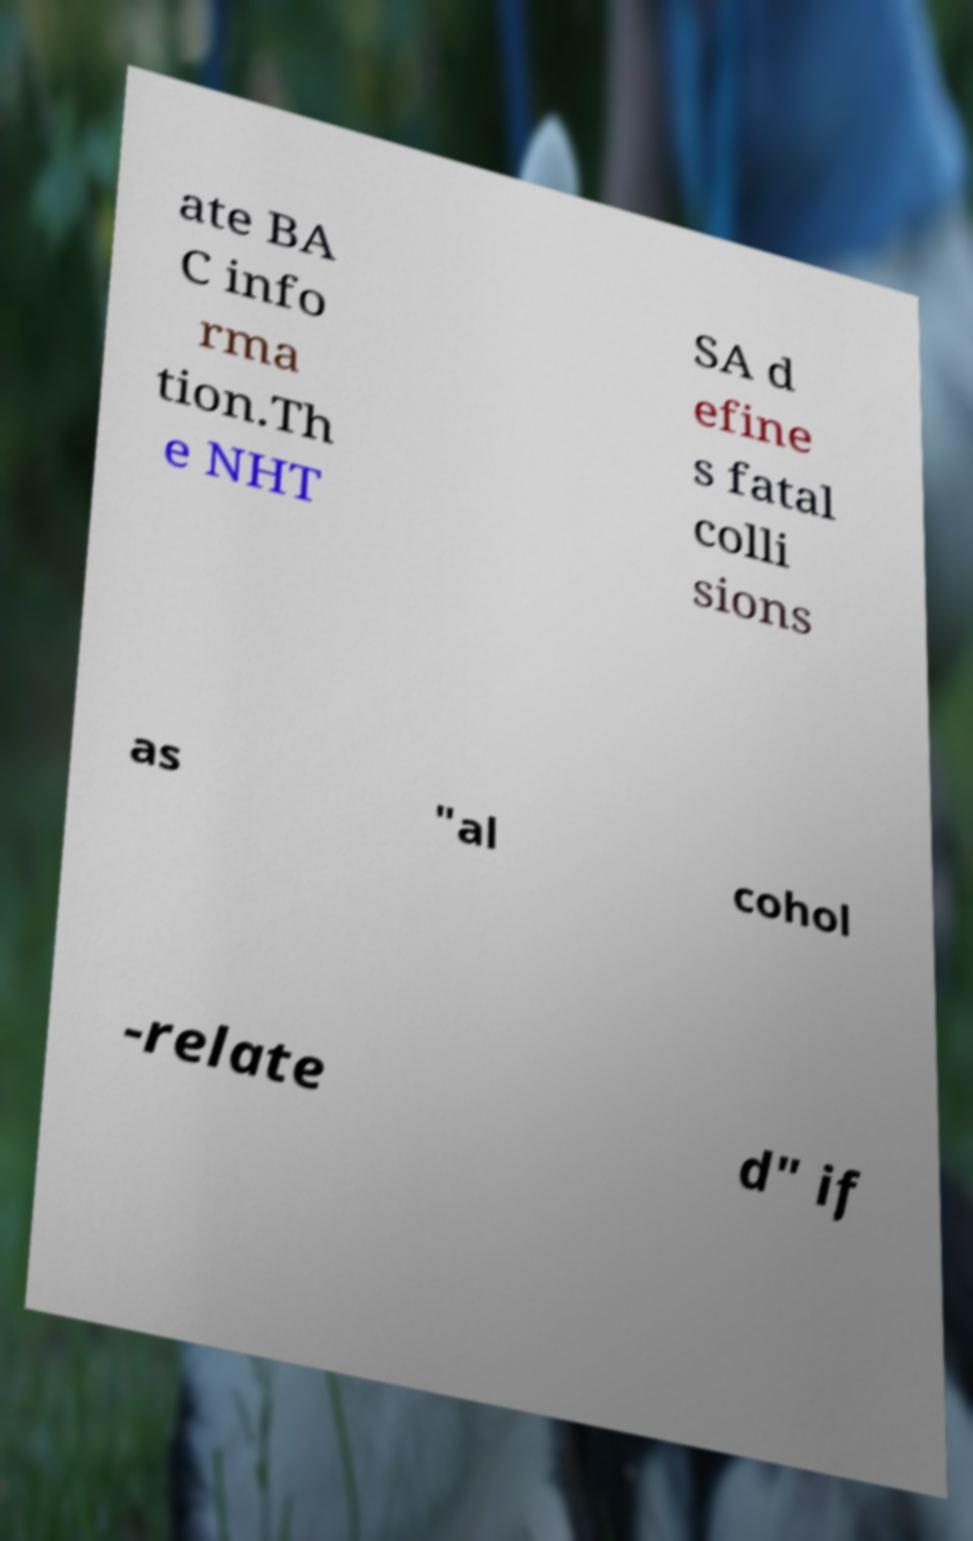Could you assist in decoding the text presented in this image and type it out clearly? ate BA C info rma tion.Th e NHT SA d efine s fatal colli sions as "al cohol -relate d" if 